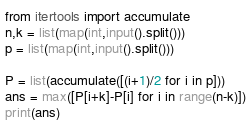<code> <loc_0><loc_0><loc_500><loc_500><_Python_>
from itertools import accumulate
n,k = list(map(int,input().split()))
p = list(map(int,input().split()))

P = list(accumulate([(i+1)/2 for i in p]))
ans = max([P[i+k]-P[i] for i in range(n-k)])
print(ans)</code> 